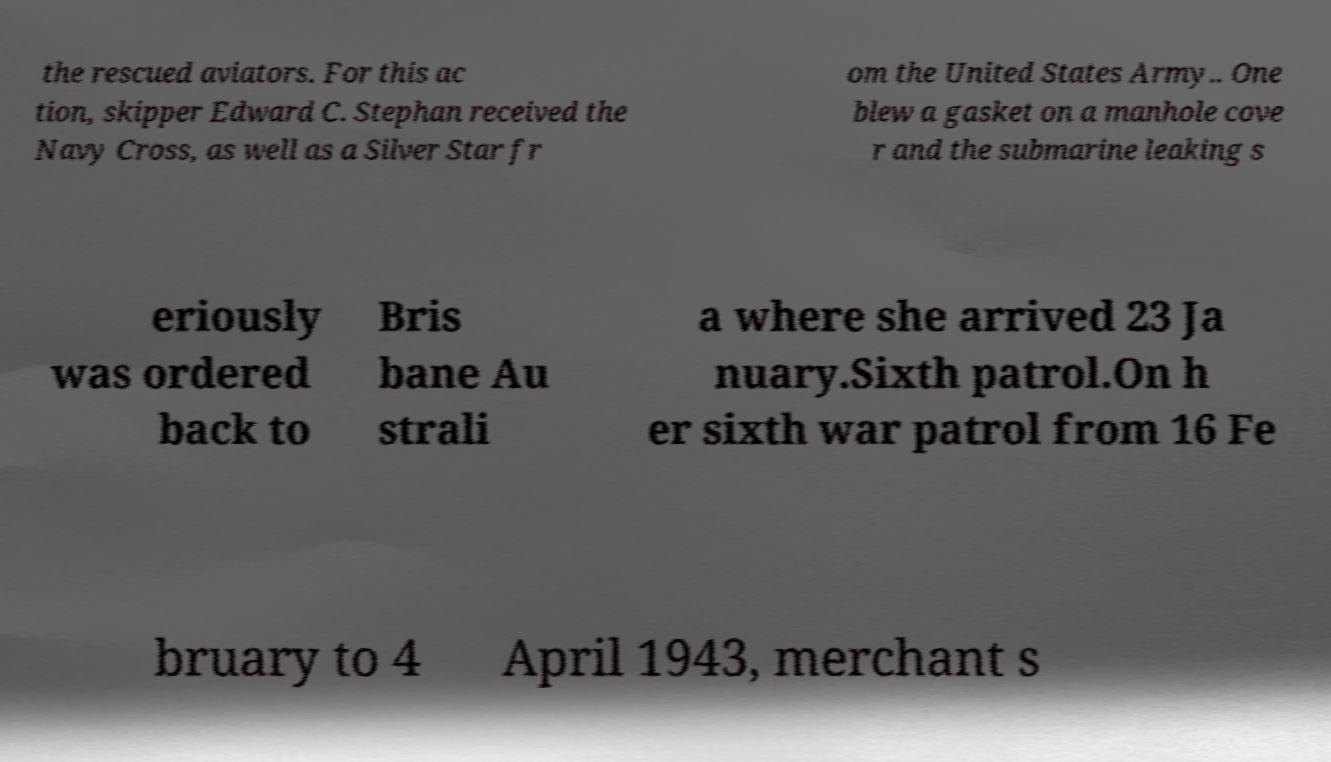I need the written content from this picture converted into text. Can you do that? the rescued aviators. For this ac tion, skipper Edward C. Stephan received the Navy Cross, as well as a Silver Star fr om the United States Army.. One blew a gasket on a manhole cove r and the submarine leaking s eriously was ordered back to Bris bane Au strali a where she arrived 23 Ja nuary.Sixth patrol.On h er sixth war patrol from 16 Fe bruary to 4 April 1943, merchant s 